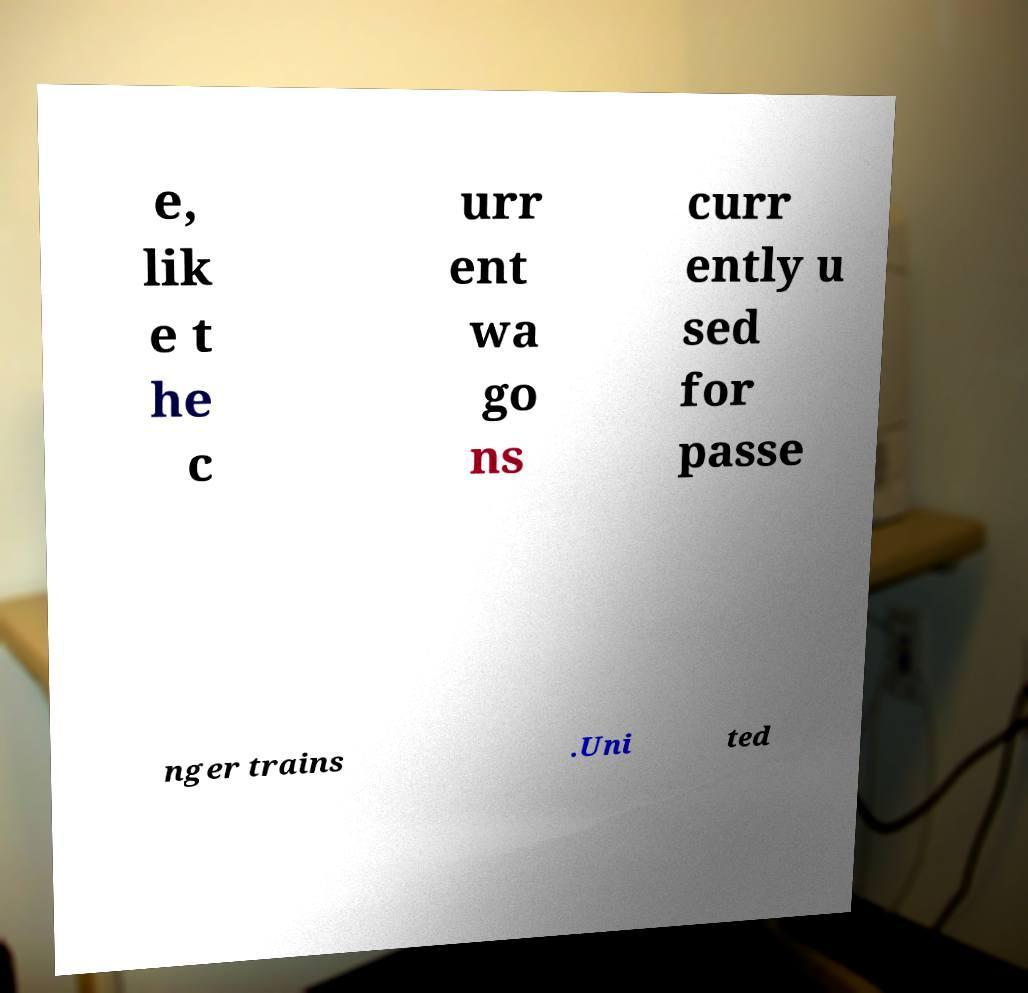Could you assist in decoding the text presented in this image and type it out clearly? e, lik e t he c urr ent wa go ns curr ently u sed for passe nger trains .Uni ted 